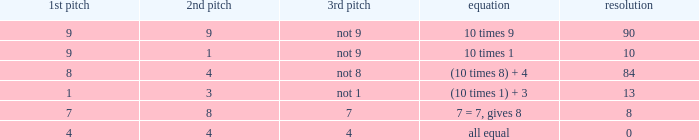What is the result when the 3rd throw is not 8? 84.0. 